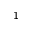<formula> <loc_0><loc_0><loc_500><loc_500>_ { 1 }</formula> 